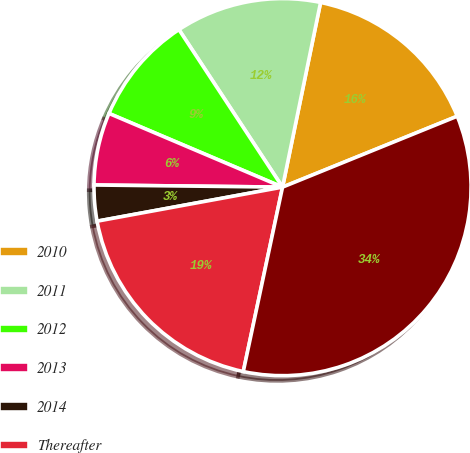<chart> <loc_0><loc_0><loc_500><loc_500><pie_chart><fcel>2010<fcel>2011<fcel>2012<fcel>2013<fcel>2014<fcel>Thereafter<fcel>Total<nl><fcel>15.63%<fcel>12.49%<fcel>9.35%<fcel>6.21%<fcel>3.07%<fcel>18.77%<fcel>34.47%<nl></chart> 